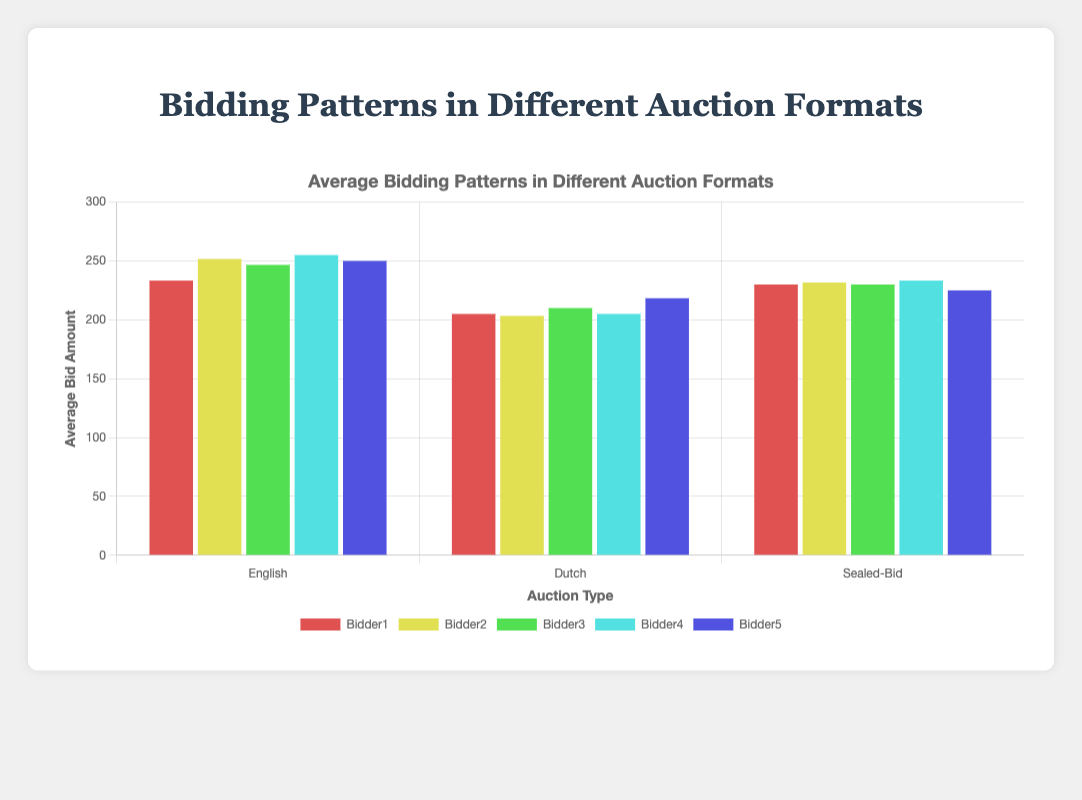What is the average bid amount for Bidder1 in English auctions? To find the average bid amount for Bidder1 in English auctions, sum the bids and then divide by the number of English auctions. The bids for Bidder1 in English auctions are 150, 230, and 320. Sum these to get 700, then divide by 3 to get approximately 233.33.
Answer: 233.33 Which auction type has the highest average bid amount for Bidder4? For English auctions, Bidder4's average bid amount is (180 + 260 + 325) / 3 = 255. For Dutch auctions, it's (130 + 205 + 280) / 3 = 205. For Sealed-Bid auctions, it's (175 + 210 + 315) / 3 = 233.33. Therefore, the English auction has the highest average bid amount for Bidder4.
Answer: English Is Bidder2's average bid amount higher in Dutch or Sealed-Bid auctions? Bidder2’s average bid amount in Dutch auctions is (135 + 190 + 285) / 3 = 203.33, whereas in Sealed-Bid auctions, it is (155 + 220 + 320) / 3 = 231.67. Therefore, Bidder2's average bid amount is higher in Sealed-Bid auctions.
Answer: Sealed-Bid What is the difference between the highest and lowest average bid amounts for Bidder3 across all auction types? The average bid amount for Bidder3 in English auctions is (160 + 240 + 340) / 3 = 246.67. For Dutch auctions, it is (140 + 195 + 295) / 3 = 210. For Sealed-Bid auctions, it is (160 + 225 + 305) / 3 = 230. The highest is 246.67 and the lowest is 210, so the difference is 246.67 - 210 = 36.67.
Answer: 36.67 Which auction type shows the most balanced (least variation) average bids across all bidders? Calculate the variance of the average bids for each auction type. For English, the average bids are 233.33, 251.67, 246.67, 255, and 250. For Dutch, they are 185, 203.33, 210, 205, and 218.33. For Sealed-Bid, they are 230, 231.67, 230, 233.33, and 225. The variance of these sets indicates that the Sealed-Bid auction exhibits the most balanced average bids.
Answer: Sealed-Bid Which bidder placed the highest average bid amount in Dutch auctions? Average bid amounts in Dutch auctions are: Bidder1: (125 + 200 + 290) / 3 = 205, Bidder2: (135 + 190 + 285) / 3 = 203.33, Bidder3: (140 + 195 + 295) / 3 = 210, Bidder4: (130 + 205 + 280) / 3 = 205, Bidder5: (145 + 210 + 300) / 3 = 218.33. The highest average bid amount was placed by Bidder5 with 218.33.
Answer: Bidder5 